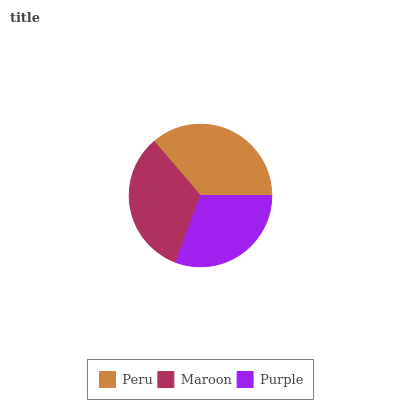Is Purple the minimum?
Answer yes or no. Yes. Is Peru the maximum?
Answer yes or no. Yes. Is Maroon the minimum?
Answer yes or no. No. Is Maroon the maximum?
Answer yes or no. No. Is Peru greater than Maroon?
Answer yes or no. Yes. Is Maroon less than Peru?
Answer yes or no. Yes. Is Maroon greater than Peru?
Answer yes or no. No. Is Peru less than Maroon?
Answer yes or no. No. Is Maroon the high median?
Answer yes or no. Yes. Is Maroon the low median?
Answer yes or no. Yes. Is Purple the high median?
Answer yes or no. No. Is Purple the low median?
Answer yes or no. No. 